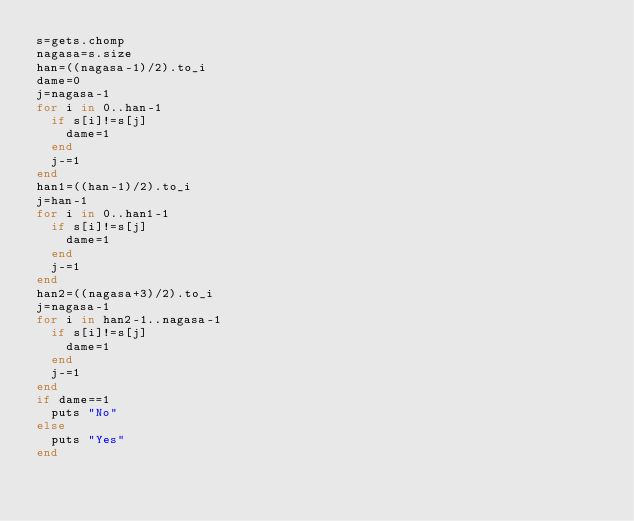Convert code to text. <code><loc_0><loc_0><loc_500><loc_500><_Ruby_>s=gets.chomp
nagasa=s.size
han=((nagasa-1)/2).to_i
dame=0
j=nagasa-1
for i in 0..han-1
  if s[i]!=s[j]
    dame=1
  end
  j-=1
end
han1=((han-1)/2).to_i
j=han-1
for i in 0..han1-1
  if s[i]!=s[j]
    dame=1
  end
  j-=1
end
han2=((nagasa+3)/2).to_i
j=nagasa-1
for i in han2-1..nagasa-1
  if s[i]!=s[j]
    dame=1
  end
  j-=1
end
if dame==1
  puts "No"
else
  puts "Yes"
end
</code> 